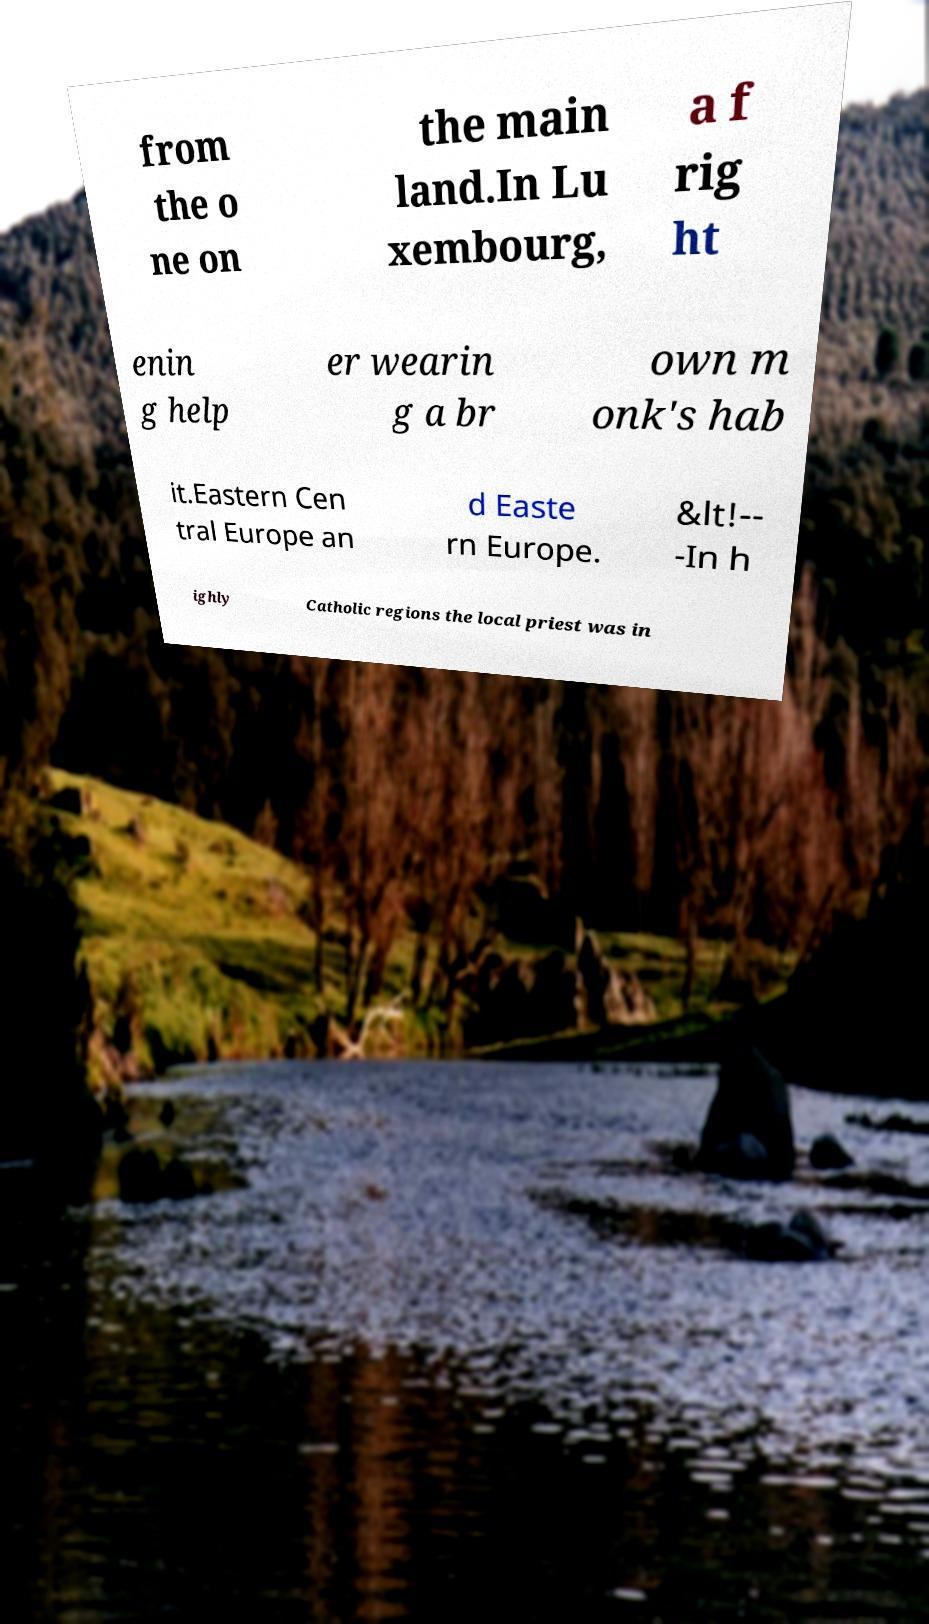For documentation purposes, I need the text within this image transcribed. Could you provide that? from the o ne on the main land.In Lu xembourg, a f rig ht enin g help er wearin g a br own m onk's hab it.Eastern Cen tral Europe an d Easte rn Europe. &lt!-- -In h ighly Catholic regions the local priest was in 